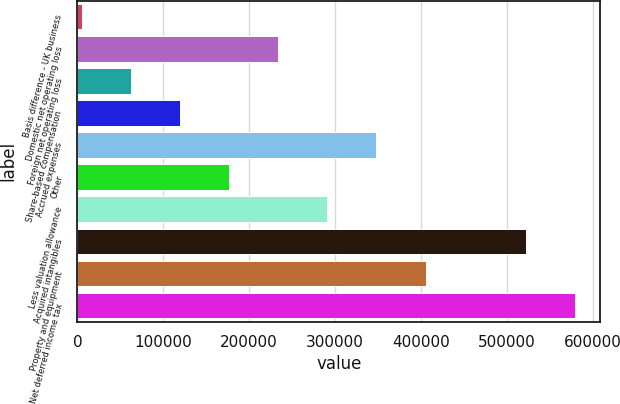Convert chart. <chart><loc_0><loc_0><loc_500><loc_500><bar_chart><fcel>Basis difference - UK business<fcel>Domestic net operating loss<fcel>Foreign net operating loss<fcel>Share-based compensation<fcel>Accrued expenses<fcel>Other<fcel>Less valuation allowance<fcel>Acquired intangibles<fcel>Property and equipment<fcel>Net deferred income tax<nl><fcel>4890<fcel>233693<fcel>62090.7<fcel>119291<fcel>348094<fcel>176492<fcel>290894<fcel>522636<fcel>405295<fcel>579837<nl></chart> 